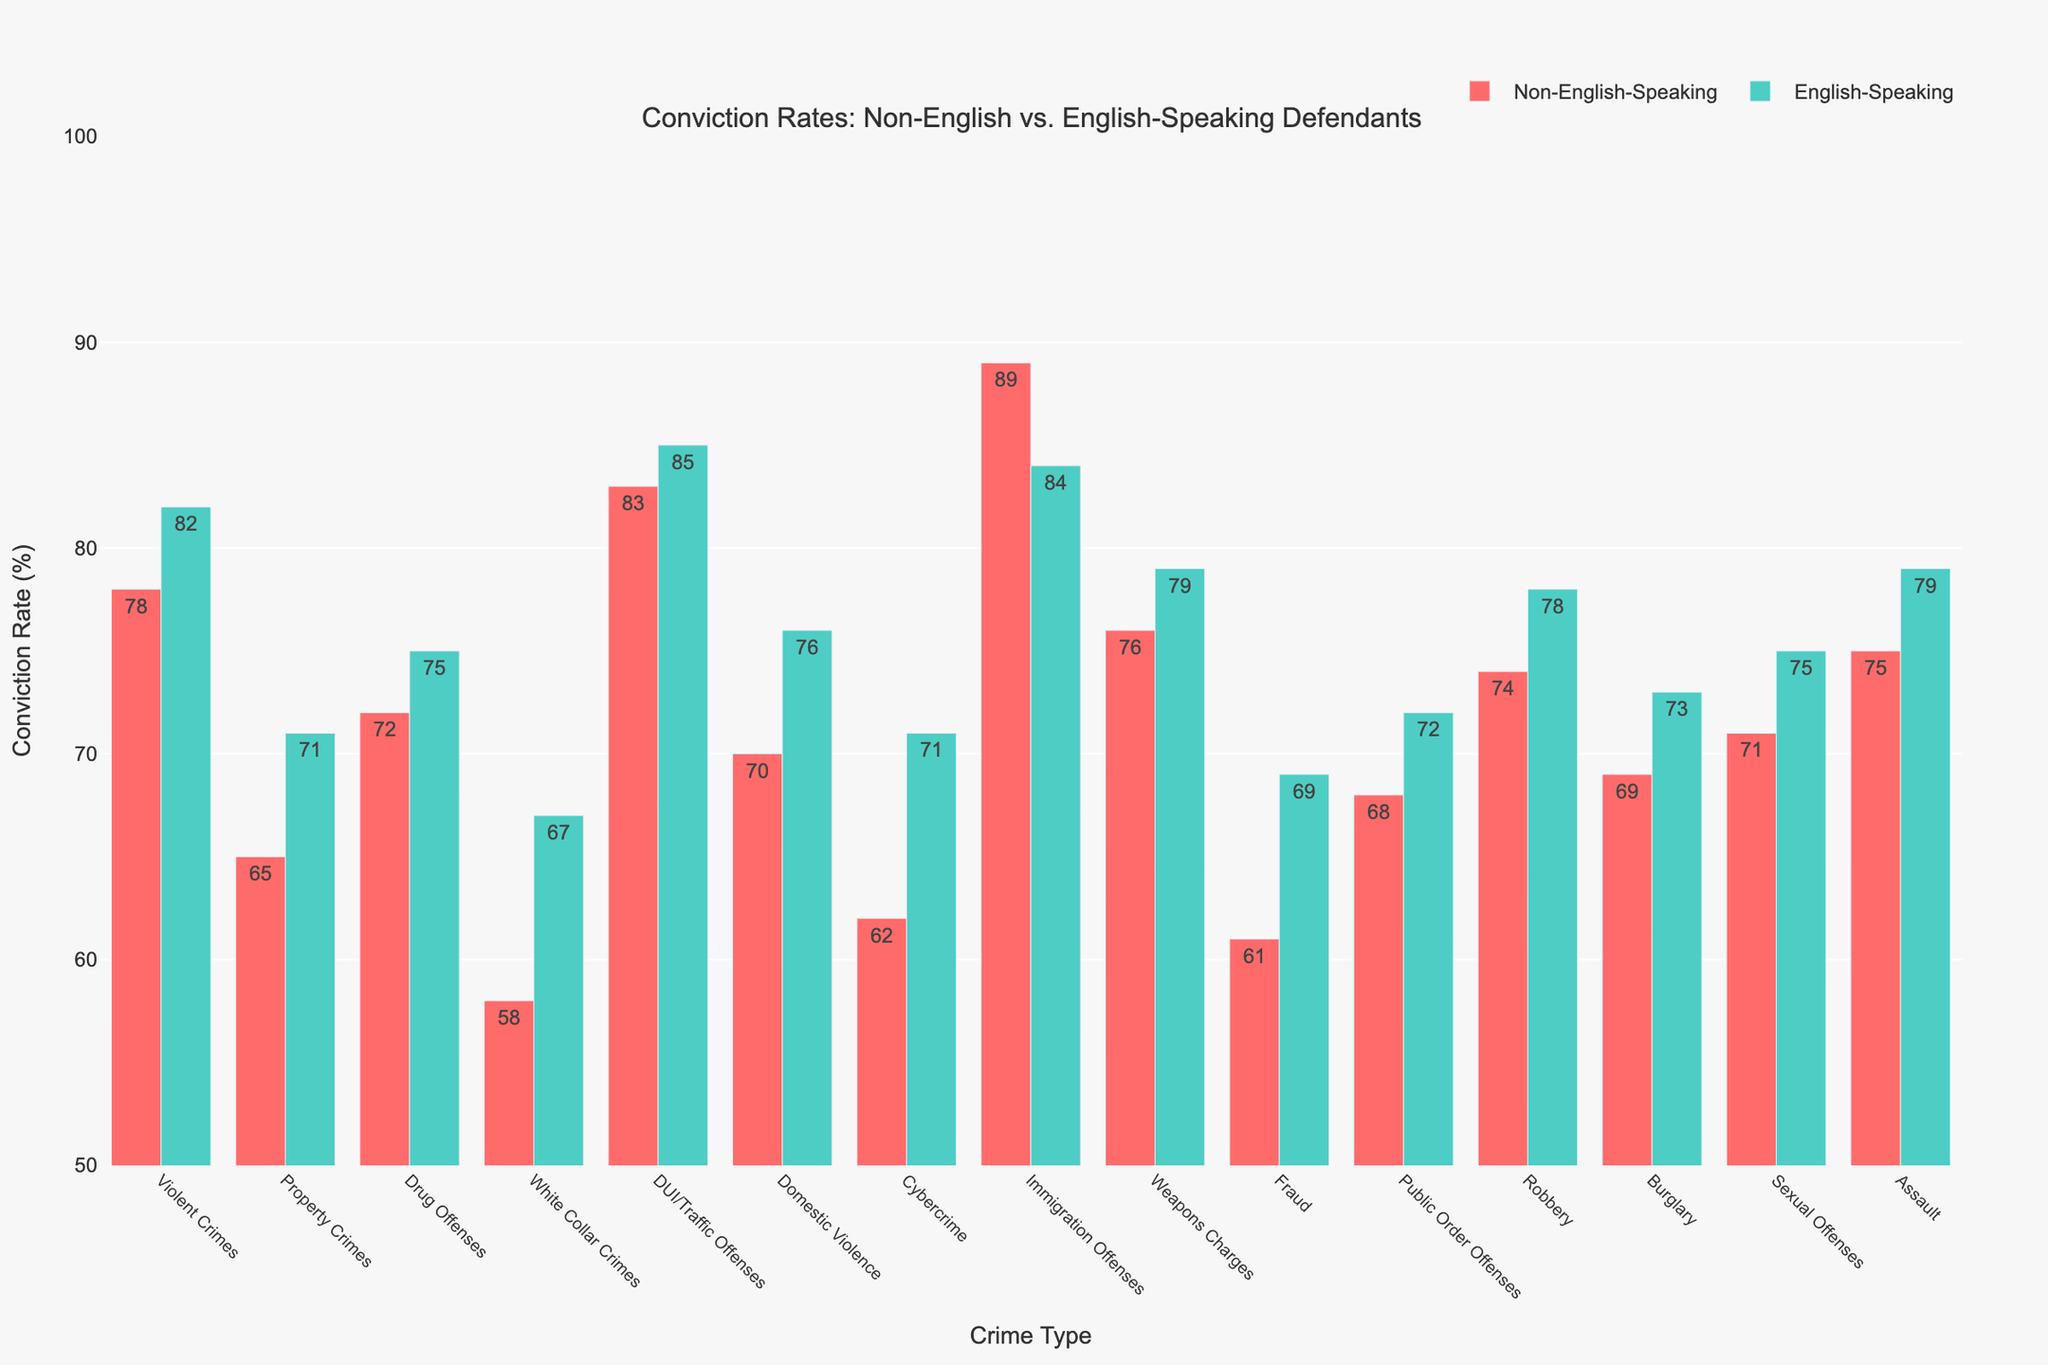Which crime type has the highest conviction rate for non-English-speaking defendants? Look at the bar heights for non-English-speaking defendants. The tallest bar corresponds to the crime with the highest conviction rate. In this case, it's Immigration Offenses with a conviction rate of 89%.
Answer: Immigration Offenses Which crime type has the largest difference in conviction rates between non-English-speaking and English-speaking defendants? Calculate the difference in conviction rates for each crime type. The largest difference is for White Collar Crimes, with rates of 58% and 67%, resulting in a difference of 9 percentage points.
Answer: White Collar Crimes Are there any crime types where the conviction rates for non-English-speaking defendants are higher than for English-speaking defendants? Compare the two bars for each crime type. Immigration Offenses have a higher conviction rate for non-English-speaking defendants (89%) compared to English-speaking defendants (84%).
Answer: Immigration Offenses What is the average conviction rate for English-speaking defendants across all crime types? Sum the conviction rates for English-speaking defendants and divide by the number of crime types. (82 + 71 + 75 + 67 + 85 + 76 + 71 + 84 + 79 + 69 + 72 + 78 + 73 + 75 + 79) / 15 = 76%
Answer: 76% How many crime types have a conviction rate for non-English-speaking defendants that is equal to or above 75%? Count the bars representing non-English-speaking defendants with heights of 75% or more. There are five such crimes: Violent Crimes, DUI/Traffic Offenses, Immigration Offenses, Weapons Charges, and Assault.
Answer: 5 Which crime type shows the smallest difference in conviction rates between non-English-speaking and English-speaking defendants? Calculate the difference for each crime type. DUI/Traffic Offenses have the smallest difference of 2 percentage points (83% vs 85%).
Answer: DUI/Traffic Offenses What is the median conviction rate for non-English-speaking defendants across all crime types? Arrange the rates in ascending order and find the middle value. The middle values are in the 7th and 8th positions, averaging 70% and 71% for a median of 71%.
Answer: 71% Which crime types have conviction rates between 70% to 80% for both non-English-speaking and English-speaking defendants? Identify crime types with both bars falling within 70% to 80%. This includes Violent Crimes (78% vs 82%), Drug Offenses (72% vs 75%), Domestic Violence (70% vs 76%), Robbery (74% vs 78%), and Assault (75% vs 79%).
Answer: Violent Crimes, Drug Offenses, Domestic Violence, Robbery, Assault 